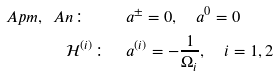<formula> <loc_0><loc_0><loc_500><loc_500>\ A p m , \ A n \colon \quad & a ^ { \pm } = 0 , \quad a ^ { 0 } = 0 \\ \mathcal { H } ^ { ( i ) } \colon \quad & a ^ { ( i ) } = - \frac { 1 } { \Omega _ { i } } , \quad i = 1 , 2</formula> 